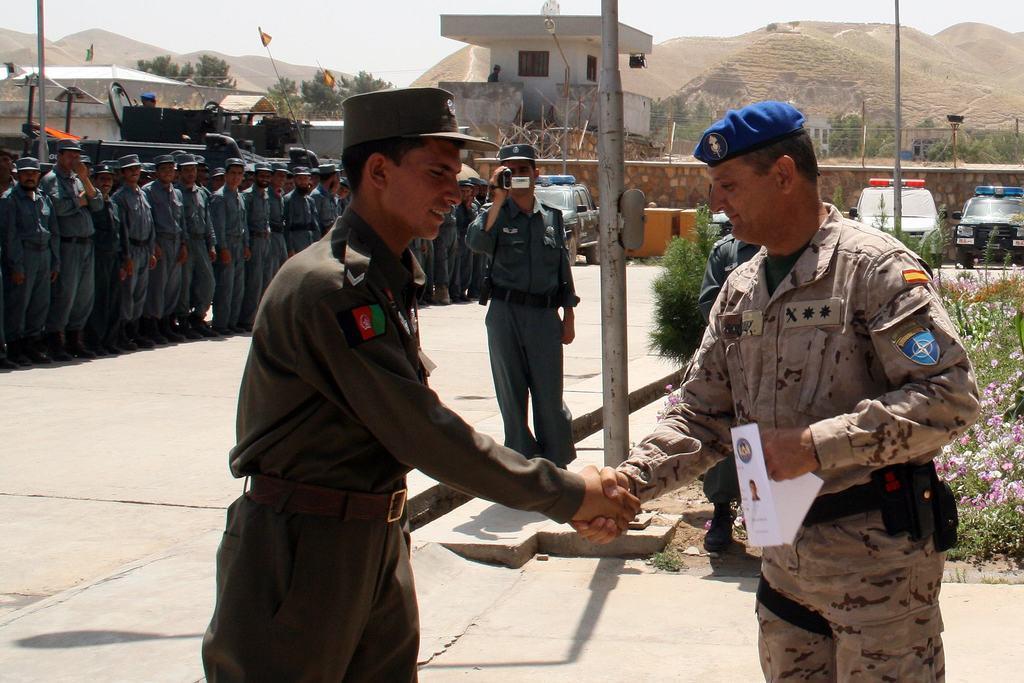In one or two sentences, can you explain what this image depicts? In the foreground I can see two persons are shaking their hands and a person is standing and is holding a camera in hand. In the background I can see a group of people are standing, light poles and vehicles on the road. At the top I can see houses, trees, fence, mountains, plants and the sky. This image is taken may be during a day. 